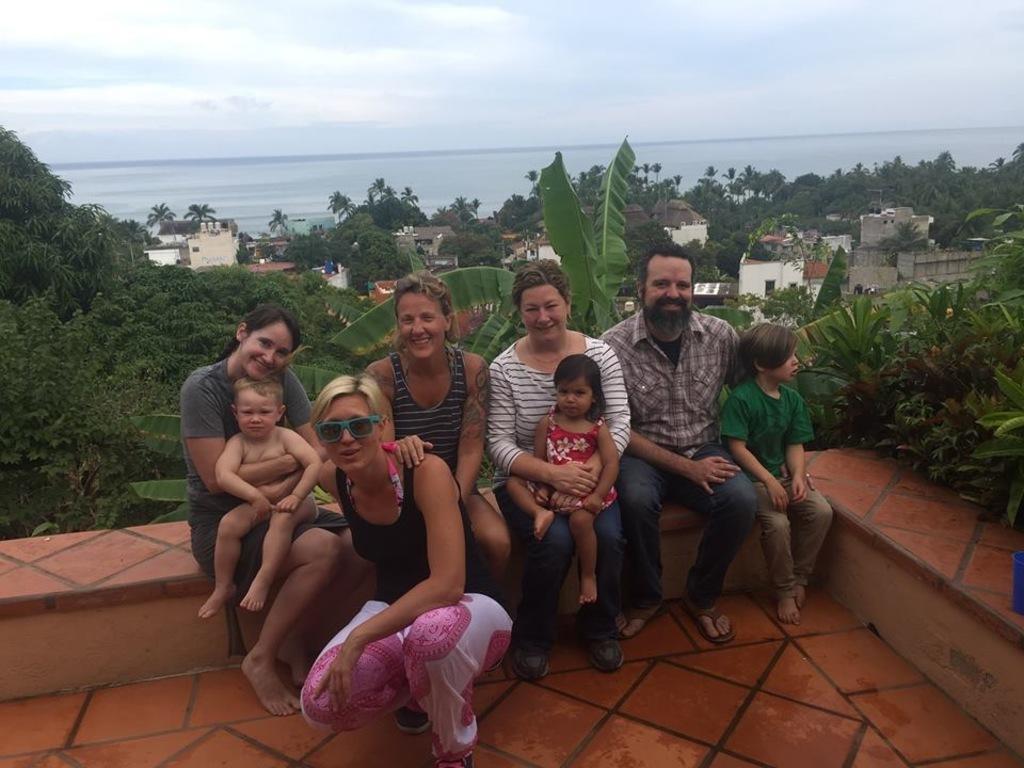Describe this image in one or two sentences. In the center of the image we can see many persons sitting on the wall. In the background we can see buildings, trees, water, sky and clouds. 